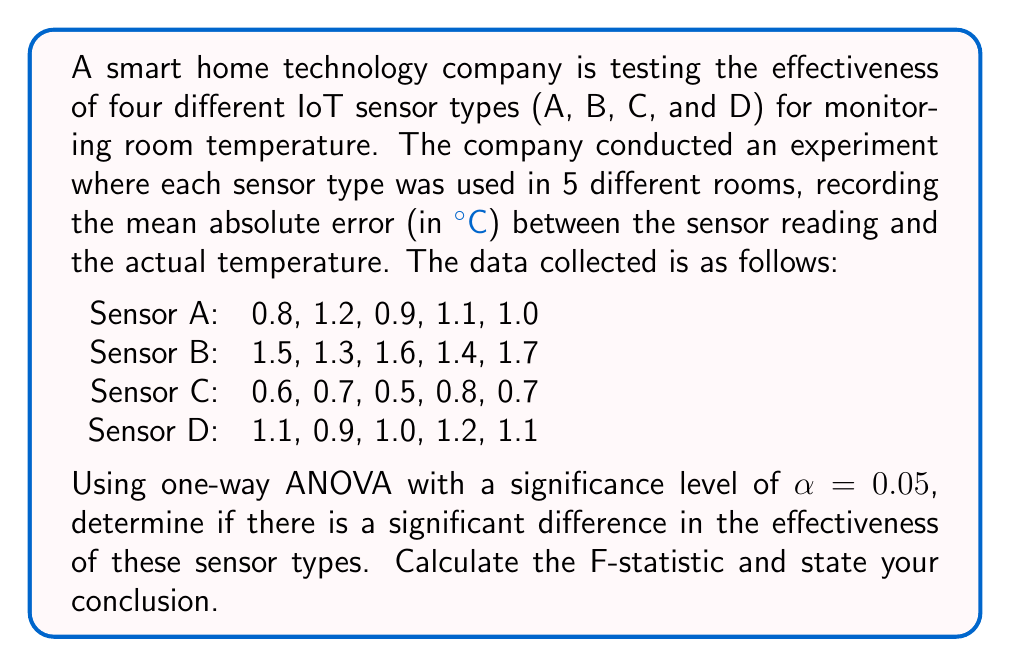Give your solution to this math problem. To solve this problem using one-way ANOVA, we'll follow these steps:

1. Calculate the sum of squares between groups (SSB)
2. Calculate the sum of squares within groups (SSW)
3. Calculate the total sum of squares (SST)
4. Determine the degrees of freedom
5. Calculate the mean squares
6. Compute the F-statistic
7. Compare the F-statistic to the critical F-value

Step 1: Calculate SSB

First, we need to calculate the grand mean and group means:

Grand mean: $\bar{X} = \frac{0.8 + 1.2 + ... + 1.1}{20} = 1.055$

Group means:
$\bar{X}_A = 1.0$
$\bar{X}_B = 1.5$
$\bar{X}_C = 0.66$
$\bar{X}_D = 1.06$

Now, we can calculate SSB:

$$SSB = \sum_{i=1}^k n_i(\bar{X}_i - \bar{X})^2$$

Where $k$ is the number of groups and $n_i$ is the number of observations in each group.

$$SSB = 5(1.0 - 1.055)^2 + 5(1.5 - 1.055)^2 + 5(0.66 - 1.055)^2 + 5(1.06 - 1.055)^2 = 2.2495$$

Step 2: Calculate SSW

$$SSW = \sum_{i=1}^k \sum_{j=1}^{n_i} (X_{ij} - \bar{X}_i)^2$$

$$SSW = [(0.8-1.0)^2 + ... + (1.0-1.0)^2] + [(1.5-1.5)^2 + ... + (1.7-1.5)^2] + [(0.6-0.66)^2 + ... + (0.7-0.66)^2] + [(1.1-1.06)^2 + ... + (1.1-1.06)^2]$$

$$SSW = 0.13 + 0.13 + 0.058 + 0.058 = 0.376$$

Step 3: Calculate SST

$$SST = SSB + SSW = 2.2495 + 0.376 = 2.6255$$

Step 4: Determine degrees of freedom

df between groups = k - 1 = 4 - 1 = 3
df within groups = N - k = 20 - 4 = 16
df total = N - 1 = 20 - 1 = 19

Step 5: Calculate mean squares

$$MSB = \frac{SSB}{df_b} = \frac{2.2495}{3} = 0.7498$$
$$MSW = \frac{SSW}{df_w} = \frac{0.376}{16} = 0.0235$$

Step 6: Compute F-statistic

$$F = \frac{MSB}{MSW} = \frac{0.7498}{0.0235} = 31.91$$

Step 7: Compare F-statistic to critical F-value

The critical F-value for α = 0.05, df_b = 3, and df_w = 16 is approximately 3.24.

Since our calculated F-statistic (31.91) is greater than the critical F-value (3.24), we reject the null hypothesis.
Answer: The calculated F-statistic is 31.91. Since this value is greater than the critical F-value of 3.24 (at α = 0.05), we conclude that there is a significant difference in the effectiveness of the four IoT sensor types for monitoring room temperature. 